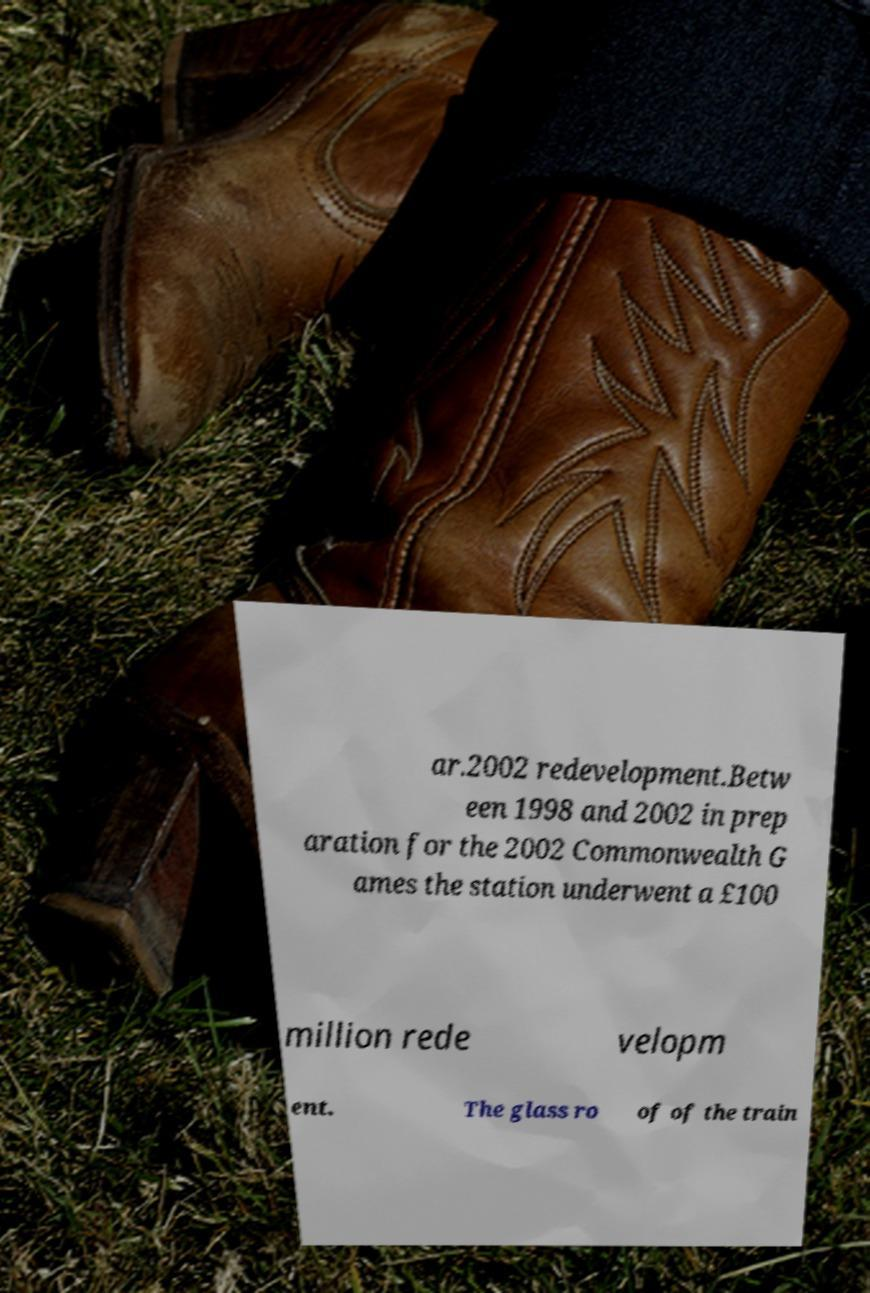I need the written content from this picture converted into text. Can you do that? ar.2002 redevelopment.Betw een 1998 and 2002 in prep aration for the 2002 Commonwealth G ames the station underwent a £100 million rede velopm ent. The glass ro of of the train 